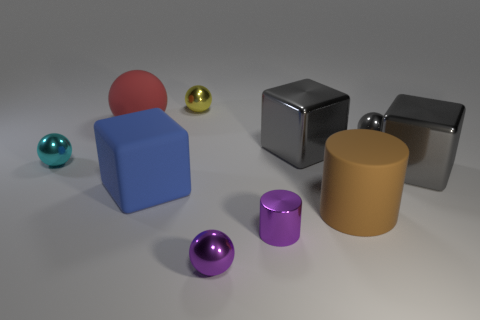What color is the cylinder that is the same material as the tiny yellow ball?
Make the answer very short. Purple. There is a purple metal thing that is the same size as the purple ball; what is its shape?
Make the answer very short. Cylinder. The cube left of the yellow metal object is what color?
Your response must be concise. Blue. What material is the brown cylinder that is the same size as the matte sphere?
Your response must be concise. Rubber. How many other things are there of the same material as the red thing?
Provide a succinct answer. 2. There is a small metallic object that is both on the right side of the small purple ball and behind the purple shiny cylinder; what color is it?
Your answer should be very brief. Gray. How many things are either cylinders that are behind the metal cylinder or red shiny cylinders?
Give a very brief answer. 1. What number of other objects are there of the same color as the small metallic cylinder?
Ensure brevity in your answer.  1. Are there the same number of big rubber cubes that are behind the blue matte cube and large cyan matte things?
Keep it short and to the point. Yes. There is a large metallic block that is behind the gray metal object in front of the cyan thing; how many gray balls are to the left of it?
Give a very brief answer. 0. 